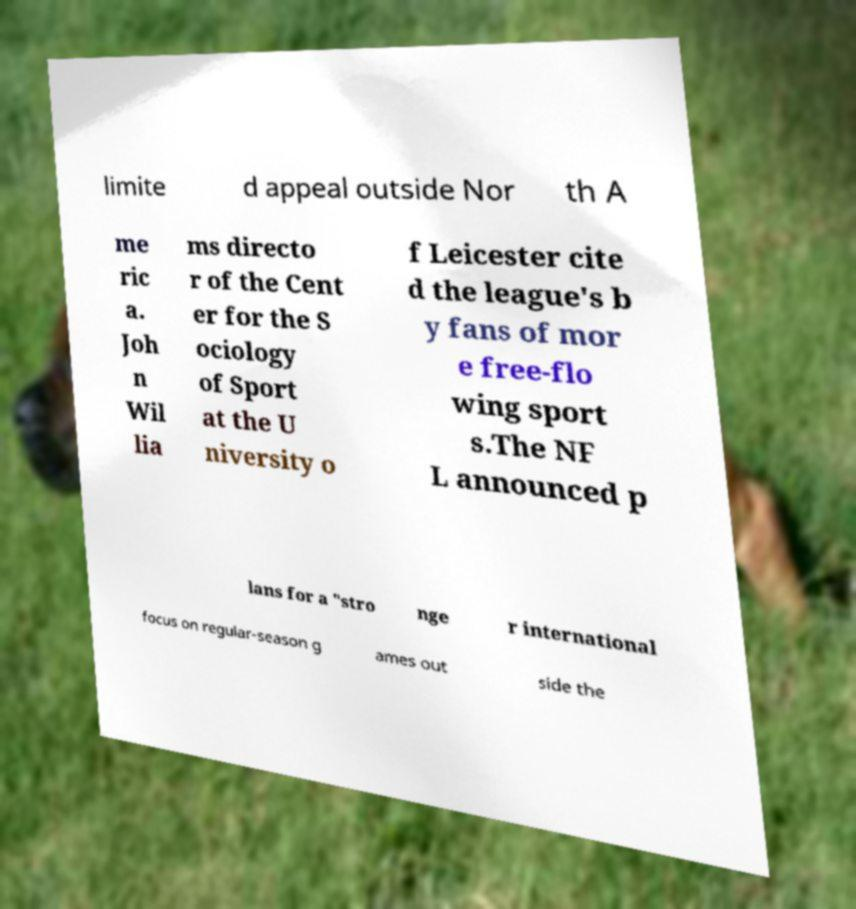For documentation purposes, I need the text within this image transcribed. Could you provide that? limite d appeal outside Nor th A me ric a. Joh n Wil lia ms directo r of the Cent er for the S ociology of Sport at the U niversity o f Leicester cite d the league's b y fans of mor e free-flo wing sport s.The NF L announced p lans for a "stro nge r international focus on regular-season g ames out side the 